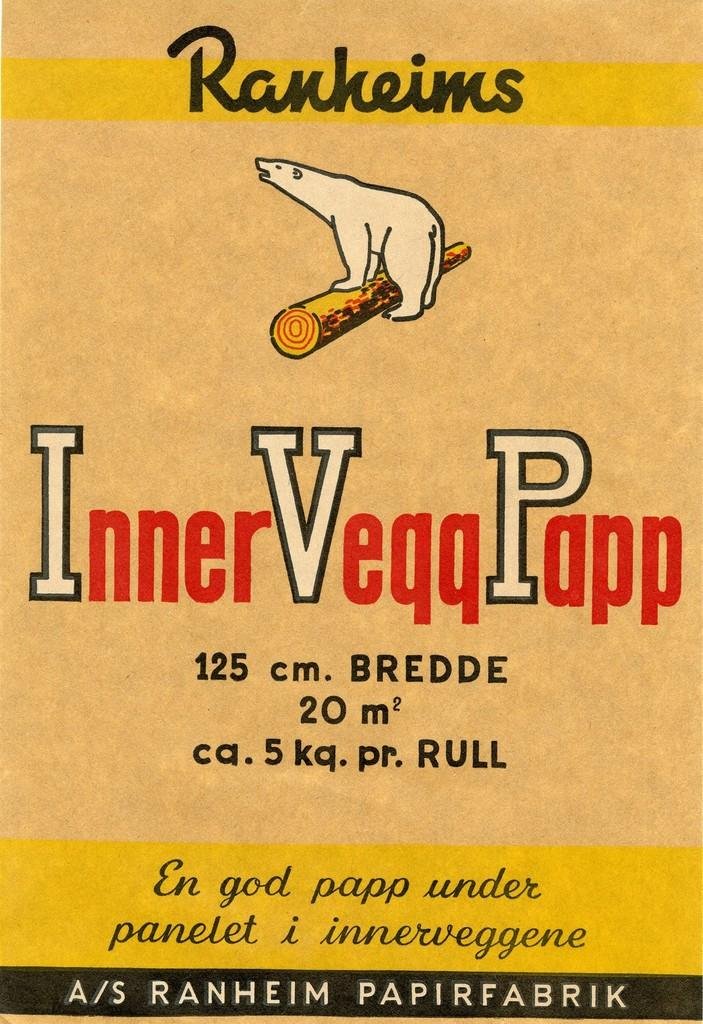<image>
Present a compact description of the photo's key features. a book with the name Ranheims at the top 